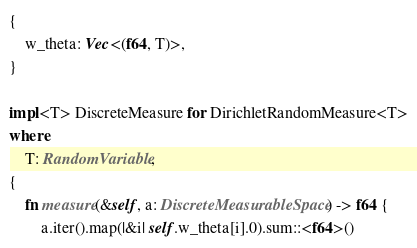Convert code to text. <code><loc_0><loc_0><loc_500><loc_500><_Rust_>{
    w_theta: Vec<(f64, T)>,
}

impl<T> DiscreteMeasure for DirichletRandomMeasure<T>
where
    T: RandomVariable,
{
    fn measure(&self, a: DiscreteMeasurableSpace) -> f64 {
        a.iter().map(|&i| self.w_theta[i].0).sum::<f64>()</code> 